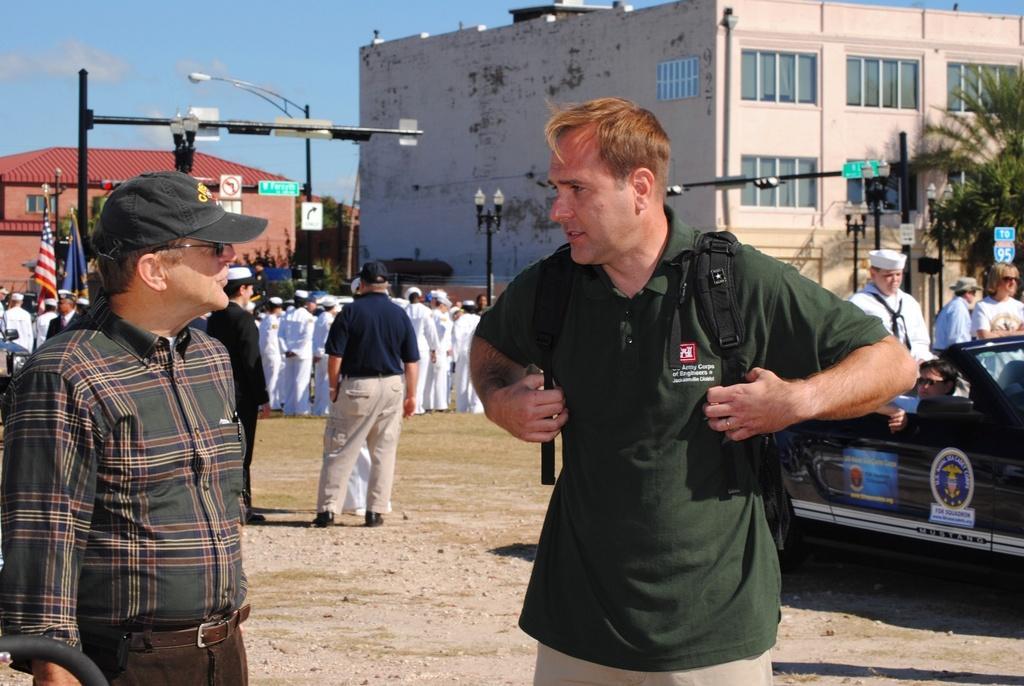Could you give a brief overview of what you see in this image? In this picture we can see some persons are standing. This is building and there is a pole. Here we can see trees. And these are the flags. On the background there is a sky with clouds. 